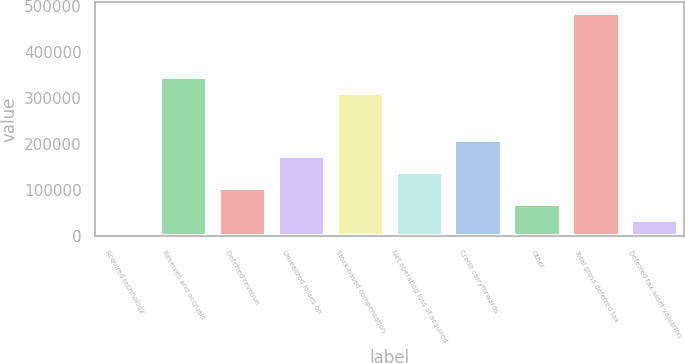Convert chart. <chart><loc_0><loc_0><loc_500><loc_500><bar_chart><fcel>Acquired technology<fcel>Reserves and accruals<fcel>Deferred revenue<fcel>Unrealized losses on<fcel>Stock-based compensation<fcel>Net operating loss of acquired<fcel>Credit carryforwards<fcel>Other<fcel>Total gross deferred tax<fcel>Deferred tax asset valuation<nl><fcel>794<fcel>346161<fcel>104404<fcel>173478<fcel>311624<fcel>138941<fcel>208014<fcel>69867.4<fcel>484308<fcel>35330.7<nl></chart> 